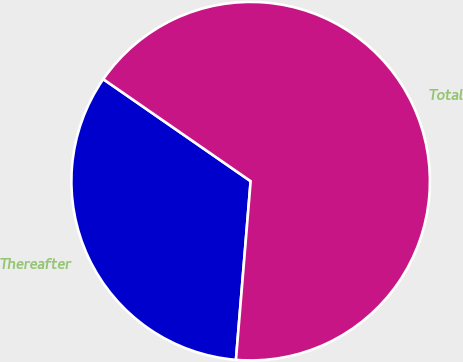Convert chart to OTSL. <chart><loc_0><loc_0><loc_500><loc_500><pie_chart><fcel>Thereafter<fcel>Total<nl><fcel>33.33%<fcel>66.67%<nl></chart> 